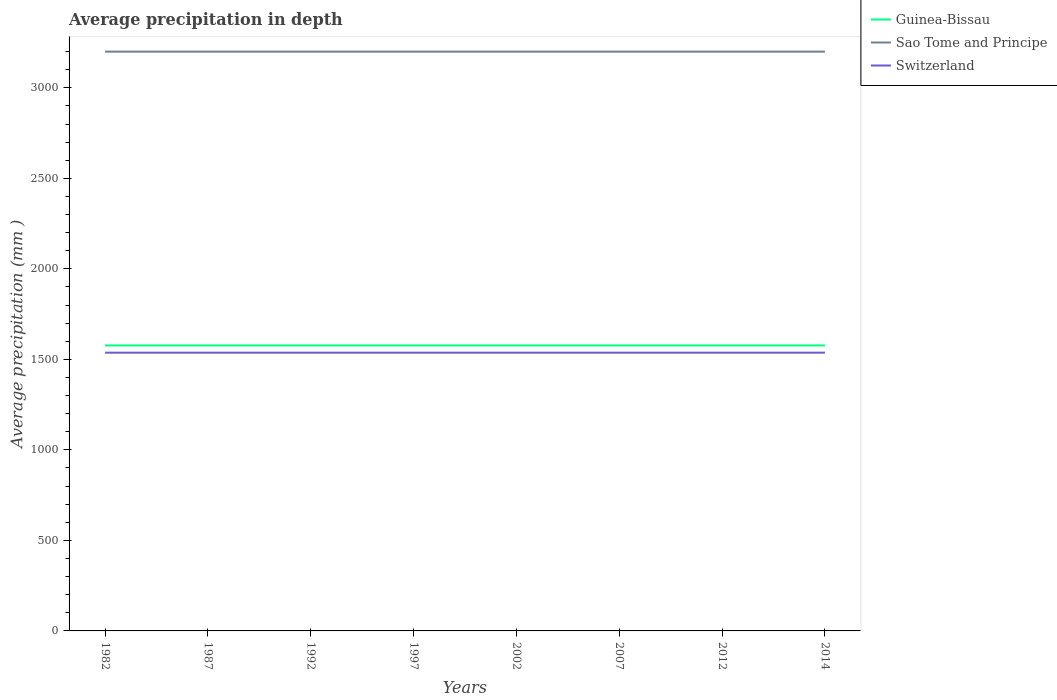How many different coloured lines are there?
Your answer should be very brief. 3. Does the line corresponding to Switzerland intersect with the line corresponding to Guinea-Bissau?
Offer a terse response. No. Is the number of lines equal to the number of legend labels?
Offer a terse response. Yes. Across all years, what is the maximum average precipitation in Switzerland?
Provide a succinct answer. 1537. In which year was the average precipitation in Sao Tome and Principe maximum?
Provide a short and direct response. 1982. What is the difference between the highest and the second highest average precipitation in Switzerland?
Your answer should be compact. 0. How many years are there in the graph?
Provide a short and direct response. 8. What is the difference between two consecutive major ticks on the Y-axis?
Ensure brevity in your answer.  500. Are the values on the major ticks of Y-axis written in scientific E-notation?
Give a very brief answer. No. Does the graph contain any zero values?
Ensure brevity in your answer.  No. Does the graph contain grids?
Keep it short and to the point. No. Where does the legend appear in the graph?
Your answer should be compact. Top right. How many legend labels are there?
Provide a short and direct response. 3. What is the title of the graph?
Provide a short and direct response. Average precipitation in depth. Does "Thailand" appear as one of the legend labels in the graph?
Your response must be concise. No. What is the label or title of the Y-axis?
Ensure brevity in your answer.  Average precipitation (mm ). What is the Average precipitation (mm ) in Guinea-Bissau in 1982?
Offer a very short reply. 1577. What is the Average precipitation (mm ) in Sao Tome and Principe in 1982?
Make the answer very short. 3200. What is the Average precipitation (mm ) in Switzerland in 1982?
Provide a succinct answer. 1537. What is the Average precipitation (mm ) of Guinea-Bissau in 1987?
Ensure brevity in your answer.  1577. What is the Average precipitation (mm ) of Sao Tome and Principe in 1987?
Make the answer very short. 3200. What is the Average precipitation (mm ) in Switzerland in 1987?
Offer a very short reply. 1537. What is the Average precipitation (mm ) in Guinea-Bissau in 1992?
Offer a terse response. 1577. What is the Average precipitation (mm ) of Sao Tome and Principe in 1992?
Provide a short and direct response. 3200. What is the Average precipitation (mm ) in Switzerland in 1992?
Provide a succinct answer. 1537. What is the Average precipitation (mm ) in Guinea-Bissau in 1997?
Ensure brevity in your answer.  1577. What is the Average precipitation (mm ) in Sao Tome and Principe in 1997?
Offer a terse response. 3200. What is the Average precipitation (mm ) in Switzerland in 1997?
Give a very brief answer. 1537. What is the Average precipitation (mm ) of Guinea-Bissau in 2002?
Offer a terse response. 1577. What is the Average precipitation (mm ) in Sao Tome and Principe in 2002?
Your answer should be very brief. 3200. What is the Average precipitation (mm ) in Switzerland in 2002?
Ensure brevity in your answer.  1537. What is the Average precipitation (mm ) in Guinea-Bissau in 2007?
Provide a succinct answer. 1577. What is the Average precipitation (mm ) in Sao Tome and Principe in 2007?
Ensure brevity in your answer.  3200. What is the Average precipitation (mm ) in Switzerland in 2007?
Offer a very short reply. 1537. What is the Average precipitation (mm ) of Guinea-Bissau in 2012?
Your answer should be compact. 1577. What is the Average precipitation (mm ) in Sao Tome and Principe in 2012?
Keep it short and to the point. 3200. What is the Average precipitation (mm ) in Switzerland in 2012?
Make the answer very short. 1537. What is the Average precipitation (mm ) in Guinea-Bissau in 2014?
Provide a short and direct response. 1577. What is the Average precipitation (mm ) of Sao Tome and Principe in 2014?
Ensure brevity in your answer.  3200. What is the Average precipitation (mm ) in Switzerland in 2014?
Offer a very short reply. 1537. Across all years, what is the maximum Average precipitation (mm ) of Guinea-Bissau?
Your answer should be very brief. 1577. Across all years, what is the maximum Average precipitation (mm ) in Sao Tome and Principe?
Ensure brevity in your answer.  3200. Across all years, what is the maximum Average precipitation (mm ) of Switzerland?
Ensure brevity in your answer.  1537. Across all years, what is the minimum Average precipitation (mm ) in Guinea-Bissau?
Your response must be concise. 1577. Across all years, what is the minimum Average precipitation (mm ) of Sao Tome and Principe?
Keep it short and to the point. 3200. Across all years, what is the minimum Average precipitation (mm ) of Switzerland?
Give a very brief answer. 1537. What is the total Average precipitation (mm ) in Guinea-Bissau in the graph?
Offer a very short reply. 1.26e+04. What is the total Average precipitation (mm ) in Sao Tome and Principe in the graph?
Your response must be concise. 2.56e+04. What is the total Average precipitation (mm ) of Switzerland in the graph?
Provide a succinct answer. 1.23e+04. What is the difference between the Average precipitation (mm ) of Sao Tome and Principe in 1982 and that in 1987?
Your answer should be very brief. 0. What is the difference between the Average precipitation (mm ) of Switzerland in 1982 and that in 1987?
Make the answer very short. 0. What is the difference between the Average precipitation (mm ) in Guinea-Bissau in 1982 and that in 1992?
Offer a very short reply. 0. What is the difference between the Average precipitation (mm ) in Sao Tome and Principe in 1982 and that in 1992?
Offer a very short reply. 0. What is the difference between the Average precipitation (mm ) of Switzerland in 1982 and that in 1992?
Keep it short and to the point. 0. What is the difference between the Average precipitation (mm ) in Guinea-Bissau in 1982 and that in 1997?
Your answer should be very brief. 0. What is the difference between the Average precipitation (mm ) in Sao Tome and Principe in 1982 and that in 1997?
Give a very brief answer. 0. What is the difference between the Average precipitation (mm ) in Switzerland in 1982 and that in 2014?
Provide a succinct answer. 0. What is the difference between the Average precipitation (mm ) of Guinea-Bissau in 1987 and that in 1992?
Give a very brief answer. 0. What is the difference between the Average precipitation (mm ) of Sao Tome and Principe in 1987 and that in 1992?
Your response must be concise. 0. What is the difference between the Average precipitation (mm ) of Switzerland in 1987 and that in 1992?
Provide a short and direct response. 0. What is the difference between the Average precipitation (mm ) in Guinea-Bissau in 1987 and that in 1997?
Provide a succinct answer. 0. What is the difference between the Average precipitation (mm ) of Sao Tome and Principe in 1987 and that in 1997?
Offer a very short reply. 0. What is the difference between the Average precipitation (mm ) of Guinea-Bissau in 1987 and that in 2002?
Provide a short and direct response. 0. What is the difference between the Average precipitation (mm ) of Sao Tome and Principe in 1987 and that in 2002?
Provide a succinct answer. 0. What is the difference between the Average precipitation (mm ) in Switzerland in 1987 and that in 2002?
Keep it short and to the point. 0. What is the difference between the Average precipitation (mm ) in Guinea-Bissau in 1987 and that in 2007?
Give a very brief answer. 0. What is the difference between the Average precipitation (mm ) of Sao Tome and Principe in 1987 and that in 2012?
Offer a terse response. 0. What is the difference between the Average precipitation (mm ) in Guinea-Bissau in 1987 and that in 2014?
Your answer should be very brief. 0. What is the difference between the Average precipitation (mm ) of Switzerland in 1987 and that in 2014?
Your answer should be compact. 0. What is the difference between the Average precipitation (mm ) in Guinea-Bissau in 1992 and that in 1997?
Your response must be concise. 0. What is the difference between the Average precipitation (mm ) in Switzerland in 1992 and that in 1997?
Your answer should be compact. 0. What is the difference between the Average precipitation (mm ) in Guinea-Bissau in 1992 and that in 2002?
Provide a short and direct response. 0. What is the difference between the Average precipitation (mm ) of Switzerland in 1992 and that in 2002?
Keep it short and to the point. 0. What is the difference between the Average precipitation (mm ) of Guinea-Bissau in 1992 and that in 2007?
Give a very brief answer. 0. What is the difference between the Average precipitation (mm ) of Sao Tome and Principe in 1992 and that in 2007?
Provide a short and direct response. 0. What is the difference between the Average precipitation (mm ) in Switzerland in 1992 and that in 2007?
Offer a very short reply. 0. What is the difference between the Average precipitation (mm ) in Guinea-Bissau in 1992 and that in 2012?
Offer a terse response. 0. What is the difference between the Average precipitation (mm ) of Sao Tome and Principe in 1992 and that in 2012?
Your answer should be very brief. 0. What is the difference between the Average precipitation (mm ) of Switzerland in 1992 and that in 2012?
Make the answer very short. 0. What is the difference between the Average precipitation (mm ) in Guinea-Bissau in 1992 and that in 2014?
Provide a short and direct response. 0. What is the difference between the Average precipitation (mm ) of Sao Tome and Principe in 1992 and that in 2014?
Keep it short and to the point. 0. What is the difference between the Average precipitation (mm ) of Sao Tome and Principe in 1997 and that in 2002?
Make the answer very short. 0. What is the difference between the Average precipitation (mm ) in Switzerland in 1997 and that in 2002?
Provide a succinct answer. 0. What is the difference between the Average precipitation (mm ) in Guinea-Bissau in 1997 and that in 2007?
Provide a short and direct response. 0. What is the difference between the Average precipitation (mm ) in Sao Tome and Principe in 1997 and that in 2007?
Your response must be concise. 0. What is the difference between the Average precipitation (mm ) of Switzerland in 1997 and that in 2007?
Keep it short and to the point. 0. What is the difference between the Average precipitation (mm ) in Sao Tome and Principe in 1997 and that in 2012?
Offer a terse response. 0. What is the difference between the Average precipitation (mm ) in Switzerland in 1997 and that in 2012?
Your answer should be compact. 0. What is the difference between the Average precipitation (mm ) in Sao Tome and Principe in 1997 and that in 2014?
Make the answer very short. 0. What is the difference between the Average precipitation (mm ) of Sao Tome and Principe in 2002 and that in 2007?
Make the answer very short. 0. What is the difference between the Average precipitation (mm ) of Sao Tome and Principe in 2002 and that in 2012?
Your response must be concise. 0. What is the difference between the Average precipitation (mm ) of Switzerland in 2002 and that in 2012?
Provide a succinct answer. 0. What is the difference between the Average precipitation (mm ) in Guinea-Bissau in 2002 and that in 2014?
Your answer should be compact. 0. What is the difference between the Average precipitation (mm ) of Sao Tome and Principe in 2002 and that in 2014?
Provide a short and direct response. 0. What is the difference between the Average precipitation (mm ) of Switzerland in 2002 and that in 2014?
Give a very brief answer. 0. What is the difference between the Average precipitation (mm ) in Guinea-Bissau in 2007 and that in 2012?
Your answer should be compact. 0. What is the difference between the Average precipitation (mm ) in Sao Tome and Principe in 2007 and that in 2012?
Give a very brief answer. 0. What is the difference between the Average precipitation (mm ) in Switzerland in 2007 and that in 2012?
Offer a very short reply. 0. What is the difference between the Average precipitation (mm ) of Guinea-Bissau in 2012 and that in 2014?
Your answer should be very brief. 0. What is the difference between the Average precipitation (mm ) in Sao Tome and Principe in 2012 and that in 2014?
Provide a short and direct response. 0. What is the difference between the Average precipitation (mm ) of Switzerland in 2012 and that in 2014?
Provide a succinct answer. 0. What is the difference between the Average precipitation (mm ) of Guinea-Bissau in 1982 and the Average precipitation (mm ) of Sao Tome and Principe in 1987?
Give a very brief answer. -1623. What is the difference between the Average precipitation (mm ) of Sao Tome and Principe in 1982 and the Average precipitation (mm ) of Switzerland in 1987?
Your answer should be very brief. 1663. What is the difference between the Average precipitation (mm ) of Guinea-Bissau in 1982 and the Average precipitation (mm ) of Sao Tome and Principe in 1992?
Keep it short and to the point. -1623. What is the difference between the Average precipitation (mm ) in Guinea-Bissau in 1982 and the Average precipitation (mm ) in Switzerland in 1992?
Provide a short and direct response. 40. What is the difference between the Average precipitation (mm ) in Sao Tome and Principe in 1982 and the Average precipitation (mm ) in Switzerland in 1992?
Provide a short and direct response. 1663. What is the difference between the Average precipitation (mm ) of Guinea-Bissau in 1982 and the Average precipitation (mm ) of Sao Tome and Principe in 1997?
Offer a very short reply. -1623. What is the difference between the Average precipitation (mm ) of Sao Tome and Principe in 1982 and the Average precipitation (mm ) of Switzerland in 1997?
Your answer should be very brief. 1663. What is the difference between the Average precipitation (mm ) of Guinea-Bissau in 1982 and the Average precipitation (mm ) of Sao Tome and Principe in 2002?
Keep it short and to the point. -1623. What is the difference between the Average precipitation (mm ) of Sao Tome and Principe in 1982 and the Average precipitation (mm ) of Switzerland in 2002?
Your answer should be very brief. 1663. What is the difference between the Average precipitation (mm ) in Guinea-Bissau in 1982 and the Average precipitation (mm ) in Sao Tome and Principe in 2007?
Provide a short and direct response. -1623. What is the difference between the Average precipitation (mm ) of Guinea-Bissau in 1982 and the Average precipitation (mm ) of Switzerland in 2007?
Your answer should be compact. 40. What is the difference between the Average precipitation (mm ) of Sao Tome and Principe in 1982 and the Average precipitation (mm ) of Switzerland in 2007?
Your answer should be compact. 1663. What is the difference between the Average precipitation (mm ) of Guinea-Bissau in 1982 and the Average precipitation (mm ) of Sao Tome and Principe in 2012?
Provide a succinct answer. -1623. What is the difference between the Average precipitation (mm ) in Guinea-Bissau in 1982 and the Average precipitation (mm ) in Switzerland in 2012?
Offer a very short reply. 40. What is the difference between the Average precipitation (mm ) of Sao Tome and Principe in 1982 and the Average precipitation (mm ) of Switzerland in 2012?
Offer a very short reply. 1663. What is the difference between the Average precipitation (mm ) of Guinea-Bissau in 1982 and the Average precipitation (mm ) of Sao Tome and Principe in 2014?
Offer a terse response. -1623. What is the difference between the Average precipitation (mm ) in Guinea-Bissau in 1982 and the Average precipitation (mm ) in Switzerland in 2014?
Keep it short and to the point. 40. What is the difference between the Average precipitation (mm ) of Sao Tome and Principe in 1982 and the Average precipitation (mm ) of Switzerland in 2014?
Offer a terse response. 1663. What is the difference between the Average precipitation (mm ) in Guinea-Bissau in 1987 and the Average precipitation (mm ) in Sao Tome and Principe in 1992?
Your answer should be very brief. -1623. What is the difference between the Average precipitation (mm ) of Sao Tome and Principe in 1987 and the Average precipitation (mm ) of Switzerland in 1992?
Provide a short and direct response. 1663. What is the difference between the Average precipitation (mm ) in Guinea-Bissau in 1987 and the Average precipitation (mm ) in Sao Tome and Principe in 1997?
Provide a short and direct response. -1623. What is the difference between the Average precipitation (mm ) of Guinea-Bissau in 1987 and the Average precipitation (mm ) of Switzerland in 1997?
Your answer should be very brief. 40. What is the difference between the Average precipitation (mm ) of Sao Tome and Principe in 1987 and the Average precipitation (mm ) of Switzerland in 1997?
Offer a terse response. 1663. What is the difference between the Average precipitation (mm ) in Guinea-Bissau in 1987 and the Average precipitation (mm ) in Sao Tome and Principe in 2002?
Provide a succinct answer. -1623. What is the difference between the Average precipitation (mm ) in Guinea-Bissau in 1987 and the Average precipitation (mm ) in Switzerland in 2002?
Offer a terse response. 40. What is the difference between the Average precipitation (mm ) in Sao Tome and Principe in 1987 and the Average precipitation (mm ) in Switzerland in 2002?
Offer a terse response. 1663. What is the difference between the Average precipitation (mm ) of Guinea-Bissau in 1987 and the Average precipitation (mm ) of Sao Tome and Principe in 2007?
Keep it short and to the point. -1623. What is the difference between the Average precipitation (mm ) of Sao Tome and Principe in 1987 and the Average precipitation (mm ) of Switzerland in 2007?
Give a very brief answer. 1663. What is the difference between the Average precipitation (mm ) in Guinea-Bissau in 1987 and the Average precipitation (mm ) in Sao Tome and Principe in 2012?
Offer a very short reply. -1623. What is the difference between the Average precipitation (mm ) in Sao Tome and Principe in 1987 and the Average precipitation (mm ) in Switzerland in 2012?
Offer a terse response. 1663. What is the difference between the Average precipitation (mm ) of Guinea-Bissau in 1987 and the Average precipitation (mm ) of Sao Tome and Principe in 2014?
Give a very brief answer. -1623. What is the difference between the Average precipitation (mm ) in Guinea-Bissau in 1987 and the Average precipitation (mm ) in Switzerland in 2014?
Make the answer very short. 40. What is the difference between the Average precipitation (mm ) of Sao Tome and Principe in 1987 and the Average precipitation (mm ) of Switzerland in 2014?
Provide a short and direct response. 1663. What is the difference between the Average precipitation (mm ) in Guinea-Bissau in 1992 and the Average precipitation (mm ) in Sao Tome and Principe in 1997?
Provide a succinct answer. -1623. What is the difference between the Average precipitation (mm ) in Sao Tome and Principe in 1992 and the Average precipitation (mm ) in Switzerland in 1997?
Provide a short and direct response. 1663. What is the difference between the Average precipitation (mm ) in Guinea-Bissau in 1992 and the Average precipitation (mm ) in Sao Tome and Principe in 2002?
Provide a succinct answer. -1623. What is the difference between the Average precipitation (mm ) of Sao Tome and Principe in 1992 and the Average precipitation (mm ) of Switzerland in 2002?
Make the answer very short. 1663. What is the difference between the Average precipitation (mm ) in Guinea-Bissau in 1992 and the Average precipitation (mm ) in Sao Tome and Principe in 2007?
Provide a short and direct response. -1623. What is the difference between the Average precipitation (mm ) in Sao Tome and Principe in 1992 and the Average precipitation (mm ) in Switzerland in 2007?
Provide a succinct answer. 1663. What is the difference between the Average precipitation (mm ) in Guinea-Bissau in 1992 and the Average precipitation (mm ) in Sao Tome and Principe in 2012?
Provide a short and direct response. -1623. What is the difference between the Average precipitation (mm ) in Sao Tome and Principe in 1992 and the Average precipitation (mm ) in Switzerland in 2012?
Your response must be concise. 1663. What is the difference between the Average precipitation (mm ) of Guinea-Bissau in 1992 and the Average precipitation (mm ) of Sao Tome and Principe in 2014?
Ensure brevity in your answer.  -1623. What is the difference between the Average precipitation (mm ) in Sao Tome and Principe in 1992 and the Average precipitation (mm ) in Switzerland in 2014?
Provide a succinct answer. 1663. What is the difference between the Average precipitation (mm ) in Guinea-Bissau in 1997 and the Average precipitation (mm ) in Sao Tome and Principe in 2002?
Your response must be concise. -1623. What is the difference between the Average precipitation (mm ) of Sao Tome and Principe in 1997 and the Average precipitation (mm ) of Switzerland in 2002?
Offer a very short reply. 1663. What is the difference between the Average precipitation (mm ) in Guinea-Bissau in 1997 and the Average precipitation (mm ) in Sao Tome and Principe in 2007?
Your answer should be very brief. -1623. What is the difference between the Average precipitation (mm ) of Guinea-Bissau in 1997 and the Average precipitation (mm ) of Switzerland in 2007?
Ensure brevity in your answer.  40. What is the difference between the Average precipitation (mm ) of Sao Tome and Principe in 1997 and the Average precipitation (mm ) of Switzerland in 2007?
Give a very brief answer. 1663. What is the difference between the Average precipitation (mm ) in Guinea-Bissau in 1997 and the Average precipitation (mm ) in Sao Tome and Principe in 2012?
Your response must be concise. -1623. What is the difference between the Average precipitation (mm ) in Sao Tome and Principe in 1997 and the Average precipitation (mm ) in Switzerland in 2012?
Offer a very short reply. 1663. What is the difference between the Average precipitation (mm ) of Guinea-Bissau in 1997 and the Average precipitation (mm ) of Sao Tome and Principe in 2014?
Provide a short and direct response. -1623. What is the difference between the Average precipitation (mm ) in Guinea-Bissau in 1997 and the Average precipitation (mm ) in Switzerland in 2014?
Offer a very short reply. 40. What is the difference between the Average precipitation (mm ) of Sao Tome and Principe in 1997 and the Average precipitation (mm ) of Switzerland in 2014?
Keep it short and to the point. 1663. What is the difference between the Average precipitation (mm ) in Guinea-Bissau in 2002 and the Average precipitation (mm ) in Sao Tome and Principe in 2007?
Give a very brief answer. -1623. What is the difference between the Average precipitation (mm ) of Sao Tome and Principe in 2002 and the Average precipitation (mm ) of Switzerland in 2007?
Your response must be concise. 1663. What is the difference between the Average precipitation (mm ) of Guinea-Bissau in 2002 and the Average precipitation (mm ) of Sao Tome and Principe in 2012?
Offer a very short reply. -1623. What is the difference between the Average precipitation (mm ) of Sao Tome and Principe in 2002 and the Average precipitation (mm ) of Switzerland in 2012?
Offer a terse response. 1663. What is the difference between the Average precipitation (mm ) of Guinea-Bissau in 2002 and the Average precipitation (mm ) of Sao Tome and Principe in 2014?
Provide a succinct answer. -1623. What is the difference between the Average precipitation (mm ) in Sao Tome and Principe in 2002 and the Average precipitation (mm ) in Switzerland in 2014?
Your response must be concise. 1663. What is the difference between the Average precipitation (mm ) of Guinea-Bissau in 2007 and the Average precipitation (mm ) of Sao Tome and Principe in 2012?
Your answer should be compact. -1623. What is the difference between the Average precipitation (mm ) of Sao Tome and Principe in 2007 and the Average precipitation (mm ) of Switzerland in 2012?
Give a very brief answer. 1663. What is the difference between the Average precipitation (mm ) in Guinea-Bissau in 2007 and the Average precipitation (mm ) in Sao Tome and Principe in 2014?
Offer a very short reply. -1623. What is the difference between the Average precipitation (mm ) in Sao Tome and Principe in 2007 and the Average precipitation (mm ) in Switzerland in 2014?
Your answer should be very brief. 1663. What is the difference between the Average precipitation (mm ) in Guinea-Bissau in 2012 and the Average precipitation (mm ) in Sao Tome and Principe in 2014?
Your answer should be very brief. -1623. What is the difference between the Average precipitation (mm ) of Guinea-Bissau in 2012 and the Average precipitation (mm ) of Switzerland in 2014?
Make the answer very short. 40. What is the difference between the Average precipitation (mm ) in Sao Tome and Principe in 2012 and the Average precipitation (mm ) in Switzerland in 2014?
Your answer should be very brief. 1663. What is the average Average precipitation (mm ) in Guinea-Bissau per year?
Ensure brevity in your answer.  1577. What is the average Average precipitation (mm ) in Sao Tome and Principe per year?
Provide a short and direct response. 3200. What is the average Average precipitation (mm ) of Switzerland per year?
Keep it short and to the point. 1537. In the year 1982, what is the difference between the Average precipitation (mm ) of Guinea-Bissau and Average precipitation (mm ) of Sao Tome and Principe?
Offer a terse response. -1623. In the year 1982, what is the difference between the Average precipitation (mm ) of Sao Tome and Principe and Average precipitation (mm ) of Switzerland?
Offer a terse response. 1663. In the year 1987, what is the difference between the Average precipitation (mm ) of Guinea-Bissau and Average precipitation (mm ) of Sao Tome and Principe?
Keep it short and to the point. -1623. In the year 1987, what is the difference between the Average precipitation (mm ) of Sao Tome and Principe and Average precipitation (mm ) of Switzerland?
Provide a succinct answer. 1663. In the year 1992, what is the difference between the Average precipitation (mm ) of Guinea-Bissau and Average precipitation (mm ) of Sao Tome and Principe?
Your answer should be compact. -1623. In the year 1992, what is the difference between the Average precipitation (mm ) of Sao Tome and Principe and Average precipitation (mm ) of Switzerland?
Your answer should be compact. 1663. In the year 1997, what is the difference between the Average precipitation (mm ) in Guinea-Bissau and Average precipitation (mm ) in Sao Tome and Principe?
Provide a succinct answer. -1623. In the year 1997, what is the difference between the Average precipitation (mm ) of Sao Tome and Principe and Average precipitation (mm ) of Switzerland?
Give a very brief answer. 1663. In the year 2002, what is the difference between the Average precipitation (mm ) of Guinea-Bissau and Average precipitation (mm ) of Sao Tome and Principe?
Provide a succinct answer. -1623. In the year 2002, what is the difference between the Average precipitation (mm ) of Sao Tome and Principe and Average precipitation (mm ) of Switzerland?
Keep it short and to the point. 1663. In the year 2007, what is the difference between the Average precipitation (mm ) in Guinea-Bissau and Average precipitation (mm ) in Sao Tome and Principe?
Your answer should be compact. -1623. In the year 2007, what is the difference between the Average precipitation (mm ) in Guinea-Bissau and Average precipitation (mm ) in Switzerland?
Your answer should be compact. 40. In the year 2007, what is the difference between the Average precipitation (mm ) in Sao Tome and Principe and Average precipitation (mm ) in Switzerland?
Provide a succinct answer. 1663. In the year 2012, what is the difference between the Average precipitation (mm ) of Guinea-Bissau and Average precipitation (mm ) of Sao Tome and Principe?
Your answer should be compact. -1623. In the year 2012, what is the difference between the Average precipitation (mm ) in Sao Tome and Principe and Average precipitation (mm ) in Switzerland?
Provide a succinct answer. 1663. In the year 2014, what is the difference between the Average precipitation (mm ) in Guinea-Bissau and Average precipitation (mm ) in Sao Tome and Principe?
Your response must be concise. -1623. In the year 2014, what is the difference between the Average precipitation (mm ) of Sao Tome and Principe and Average precipitation (mm ) of Switzerland?
Provide a short and direct response. 1663. What is the ratio of the Average precipitation (mm ) of Guinea-Bissau in 1982 to that in 1987?
Make the answer very short. 1. What is the ratio of the Average precipitation (mm ) in Switzerland in 1982 to that in 1987?
Your answer should be very brief. 1. What is the ratio of the Average precipitation (mm ) of Sao Tome and Principe in 1982 to that in 1992?
Provide a succinct answer. 1. What is the ratio of the Average precipitation (mm ) of Guinea-Bissau in 1982 to that in 1997?
Offer a terse response. 1. What is the ratio of the Average precipitation (mm ) in Sao Tome and Principe in 1982 to that in 1997?
Make the answer very short. 1. What is the ratio of the Average precipitation (mm ) of Switzerland in 1982 to that in 1997?
Provide a succinct answer. 1. What is the ratio of the Average precipitation (mm ) of Guinea-Bissau in 1982 to that in 2002?
Provide a succinct answer. 1. What is the ratio of the Average precipitation (mm ) of Sao Tome and Principe in 1982 to that in 2002?
Your response must be concise. 1. What is the ratio of the Average precipitation (mm ) of Guinea-Bissau in 1982 to that in 2007?
Offer a terse response. 1. What is the ratio of the Average precipitation (mm ) of Sao Tome and Principe in 1982 to that in 2012?
Offer a terse response. 1. What is the ratio of the Average precipitation (mm ) of Guinea-Bissau in 1987 to that in 1992?
Keep it short and to the point. 1. What is the ratio of the Average precipitation (mm ) in Switzerland in 1987 to that in 1992?
Your answer should be very brief. 1. What is the ratio of the Average precipitation (mm ) in Sao Tome and Principe in 1987 to that in 1997?
Your answer should be compact. 1. What is the ratio of the Average precipitation (mm ) of Guinea-Bissau in 1987 to that in 2002?
Make the answer very short. 1. What is the ratio of the Average precipitation (mm ) in Switzerland in 1987 to that in 2002?
Your response must be concise. 1. What is the ratio of the Average precipitation (mm ) in Guinea-Bissau in 1987 to that in 2007?
Your answer should be very brief. 1. What is the ratio of the Average precipitation (mm ) in Sao Tome and Principe in 1987 to that in 2007?
Your answer should be very brief. 1. What is the ratio of the Average precipitation (mm ) in Switzerland in 1987 to that in 2007?
Provide a short and direct response. 1. What is the ratio of the Average precipitation (mm ) in Guinea-Bissau in 1987 to that in 2012?
Offer a terse response. 1. What is the ratio of the Average precipitation (mm ) in Sao Tome and Principe in 1987 to that in 2012?
Your answer should be compact. 1. What is the ratio of the Average precipitation (mm ) of Switzerland in 1987 to that in 2012?
Your response must be concise. 1. What is the ratio of the Average precipitation (mm ) in Guinea-Bissau in 1987 to that in 2014?
Make the answer very short. 1. What is the ratio of the Average precipitation (mm ) in Sao Tome and Principe in 1987 to that in 2014?
Offer a terse response. 1. What is the ratio of the Average precipitation (mm ) in Sao Tome and Principe in 1992 to that in 1997?
Give a very brief answer. 1. What is the ratio of the Average precipitation (mm ) in Guinea-Bissau in 1992 to that in 2002?
Offer a terse response. 1. What is the ratio of the Average precipitation (mm ) of Sao Tome and Principe in 1992 to that in 2002?
Your response must be concise. 1. What is the ratio of the Average precipitation (mm ) of Guinea-Bissau in 1992 to that in 2007?
Offer a very short reply. 1. What is the ratio of the Average precipitation (mm ) in Sao Tome and Principe in 1992 to that in 2007?
Make the answer very short. 1. What is the ratio of the Average precipitation (mm ) of Switzerland in 1992 to that in 2007?
Ensure brevity in your answer.  1. What is the ratio of the Average precipitation (mm ) of Guinea-Bissau in 1992 to that in 2012?
Make the answer very short. 1. What is the ratio of the Average precipitation (mm ) in Guinea-Bissau in 1992 to that in 2014?
Offer a terse response. 1. What is the ratio of the Average precipitation (mm ) of Switzerland in 1992 to that in 2014?
Ensure brevity in your answer.  1. What is the ratio of the Average precipitation (mm ) of Guinea-Bissau in 1997 to that in 2002?
Keep it short and to the point. 1. What is the ratio of the Average precipitation (mm ) of Guinea-Bissau in 1997 to that in 2007?
Ensure brevity in your answer.  1. What is the ratio of the Average precipitation (mm ) in Guinea-Bissau in 1997 to that in 2012?
Offer a very short reply. 1. What is the ratio of the Average precipitation (mm ) of Guinea-Bissau in 1997 to that in 2014?
Give a very brief answer. 1. What is the ratio of the Average precipitation (mm ) of Switzerland in 1997 to that in 2014?
Provide a succinct answer. 1. What is the ratio of the Average precipitation (mm ) in Sao Tome and Principe in 2002 to that in 2007?
Provide a succinct answer. 1. What is the ratio of the Average precipitation (mm ) of Switzerland in 2002 to that in 2014?
Provide a succinct answer. 1. What is the ratio of the Average precipitation (mm ) in Sao Tome and Principe in 2007 to that in 2012?
Your answer should be very brief. 1. What is the ratio of the Average precipitation (mm ) in Guinea-Bissau in 2007 to that in 2014?
Keep it short and to the point. 1. What is the ratio of the Average precipitation (mm ) of Sao Tome and Principe in 2007 to that in 2014?
Offer a very short reply. 1. What is the difference between the highest and the lowest Average precipitation (mm ) in Guinea-Bissau?
Provide a succinct answer. 0. What is the difference between the highest and the lowest Average precipitation (mm ) in Sao Tome and Principe?
Offer a very short reply. 0. 